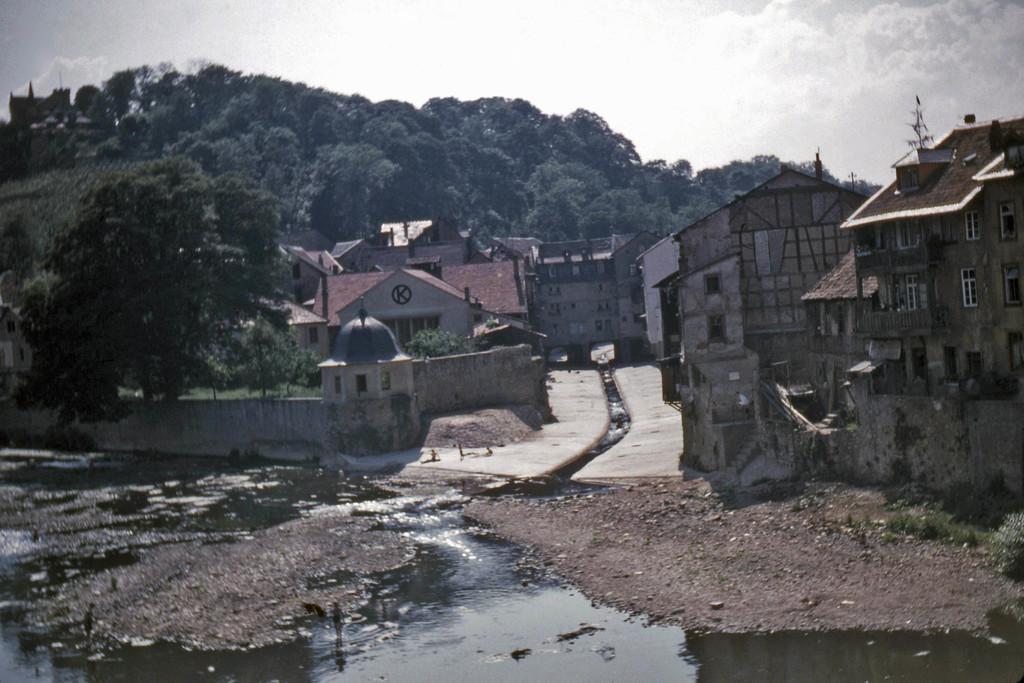How would you summarize this image in a sentence or two? In this picture we can see water at the bottom, in the background there are some trees and buildings, we can see the sky at the top of the picture, we can see grass here. 